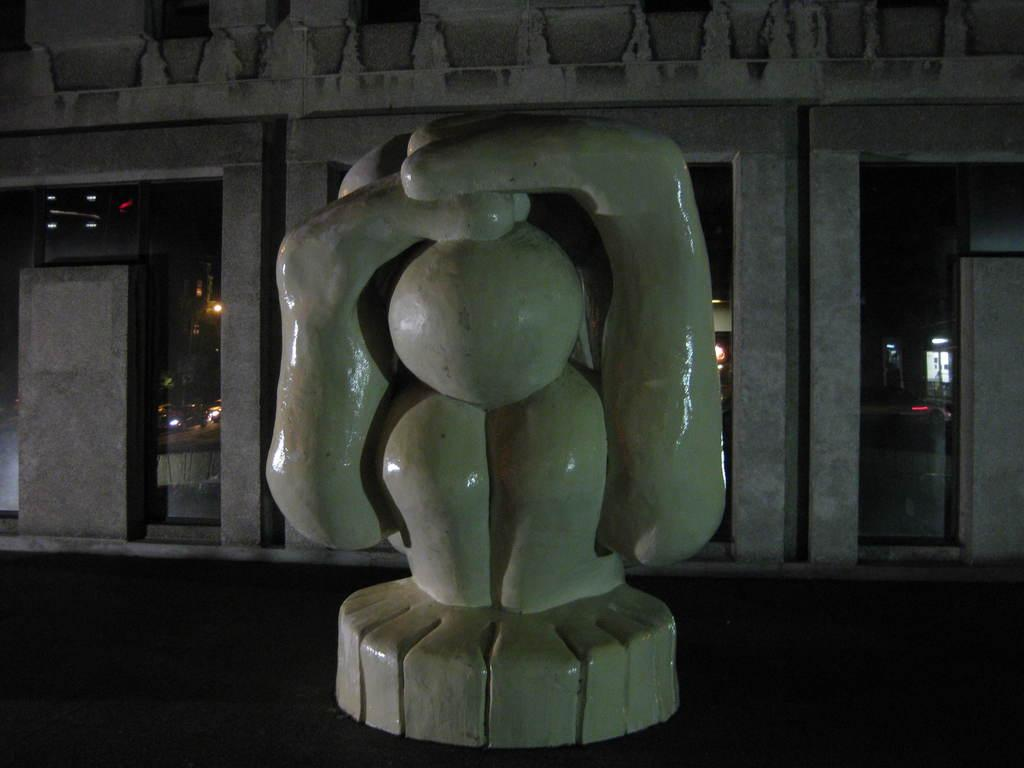What is the main object in the front of the image? There is an object in the front of the image, and it is white in color. What can be seen in the background of the image? There is a building and glasses in the background of the image. Are there any light sources visible in the image? Yes, there are lights behind the glasses. How does the object in the front of the image increase in size during the performance? The object in the front of the image does not increase in size during a performance, as there is no indication of a performance or stage in the image. 